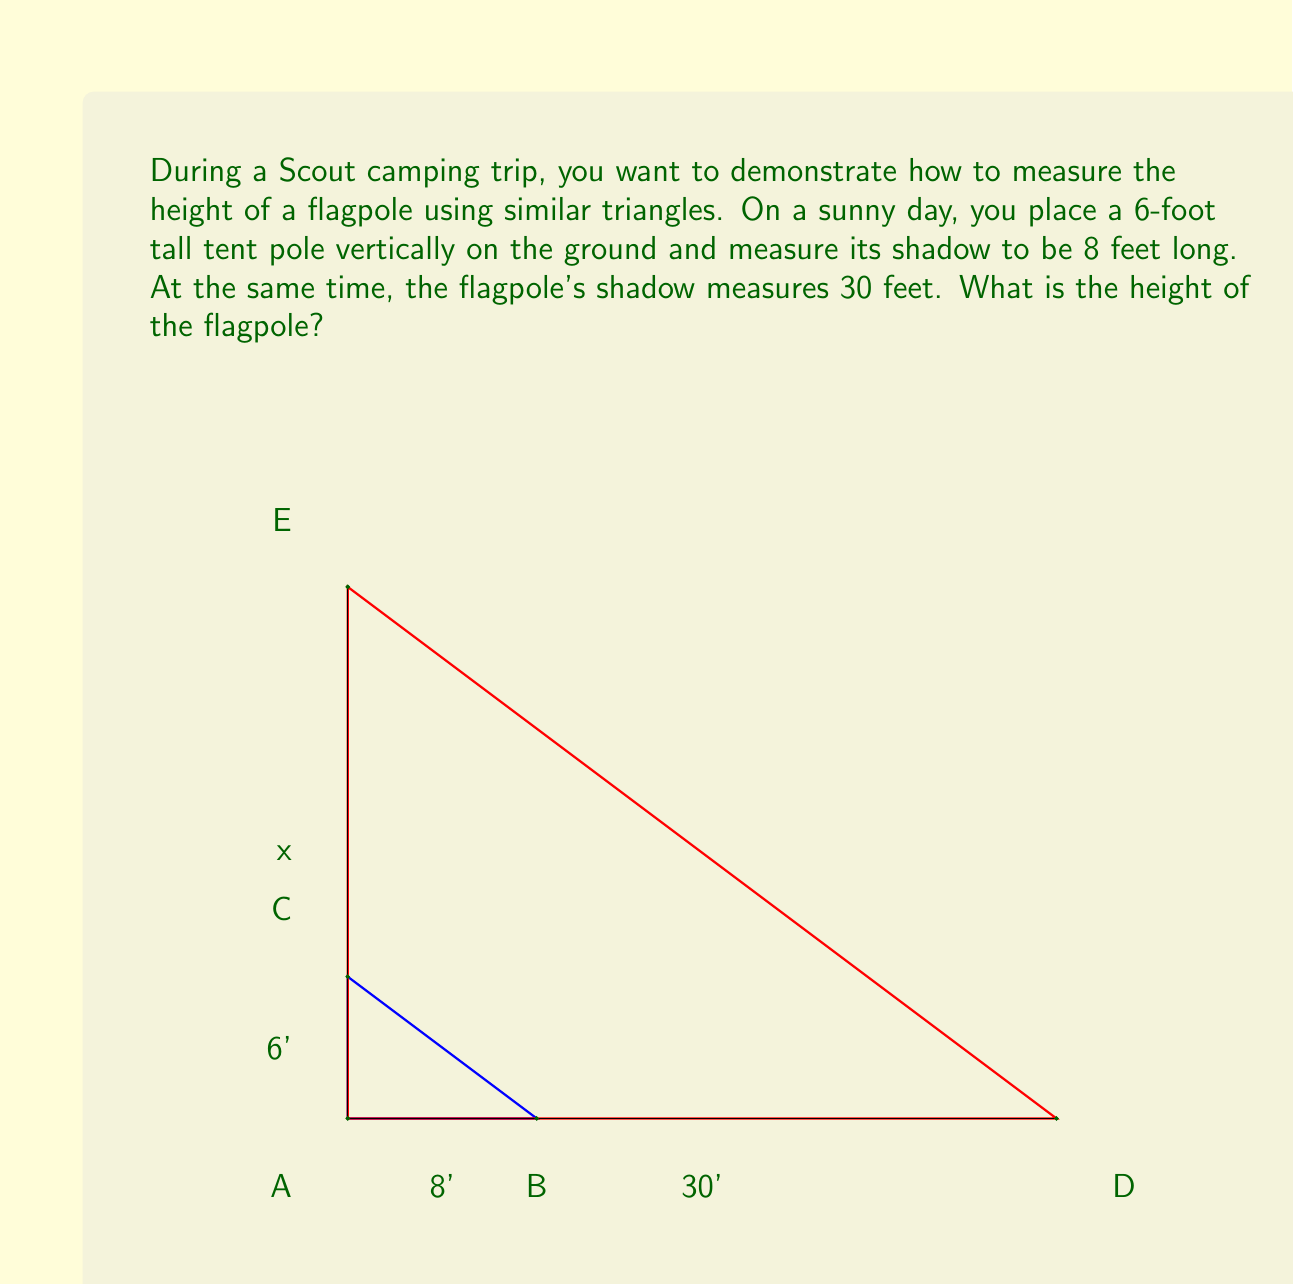Help me with this question. Let's solve this step-by-step using similar triangles:

1) We have two triangles: 
   - The smaller triangle formed by the tent pole and its shadow
   - The larger triangle formed by the flagpole and its shadow

2) These triangles are similar because:
   - They share the same angle at the base (where the pole meets the ground)
   - The sun's rays are essentially parallel, creating equal angles at the top of each pole

3) In similar triangles, the ratios of corresponding sides are equal. Let's set up this proportion:

   $$\frac{\text{tent pole height}}{\text{tent pole shadow length}} = \frac{\text{flagpole height}}{\text{flagpole shadow length}}$$

4) Let $x$ be the height of the flagpole. We can now write:

   $$\frac{6}{8} = \frac{x}{30}$$

5) Cross multiply:

   $$6 \cdot 30 = 8x$$

6) Simplify:

   $$180 = 8x$$

7) Divide both sides by 8:

   $$\frac{180}{8} = x$$

8) Simplify:

   $$22.5 = x$$

Therefore, the height of the flagpole is 22.5 feet.
Answer: 22.5 feet 